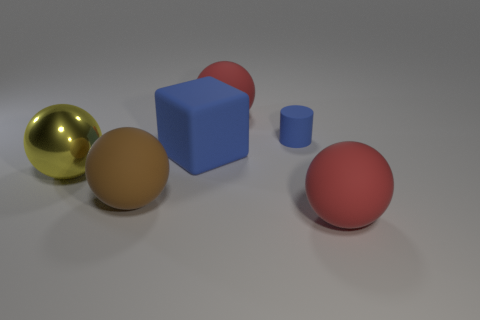Is there anything else that is the same size as the blue cylinder?
Your answer should be very brief. No. There is a block that is the same color as the small rubber object; what is its size?
Offer a very short reply. Large. Are there fewer tiny gray cubes than rubber balls?
Your answer should be very brief. Yes. Do the large rubber block that is to the right of the yellow shiny ball and the rubber cylinder have the same color?
Make the answer very short. Yes. There is a big red ball right of the big red matte object that is behind the red matte sphere that is in front of the large blue block; what is it made of?
Make the answer very short. Rubber. Are there any cylinders of the same color as the large rubber cube?
Keep it short and to the point. Yes. Is the number of large blue rubber objects left of the blue cylinder less than the number of tiny green matte blocks?
Your answer should be compact. No. There is a red matte thing in front of the brown matte ball; is its size the same as the big matte block?
Your answer should be compact. Yes. What number of balls are both right of the big brown sphere and in front of the large yellow metallic ball?
Provide a short and direct response. 1. There is a red object that is behind the red rubber sphere in front of the small rubber object; how big is it?
Ensure brevity in your answer.  Large. 